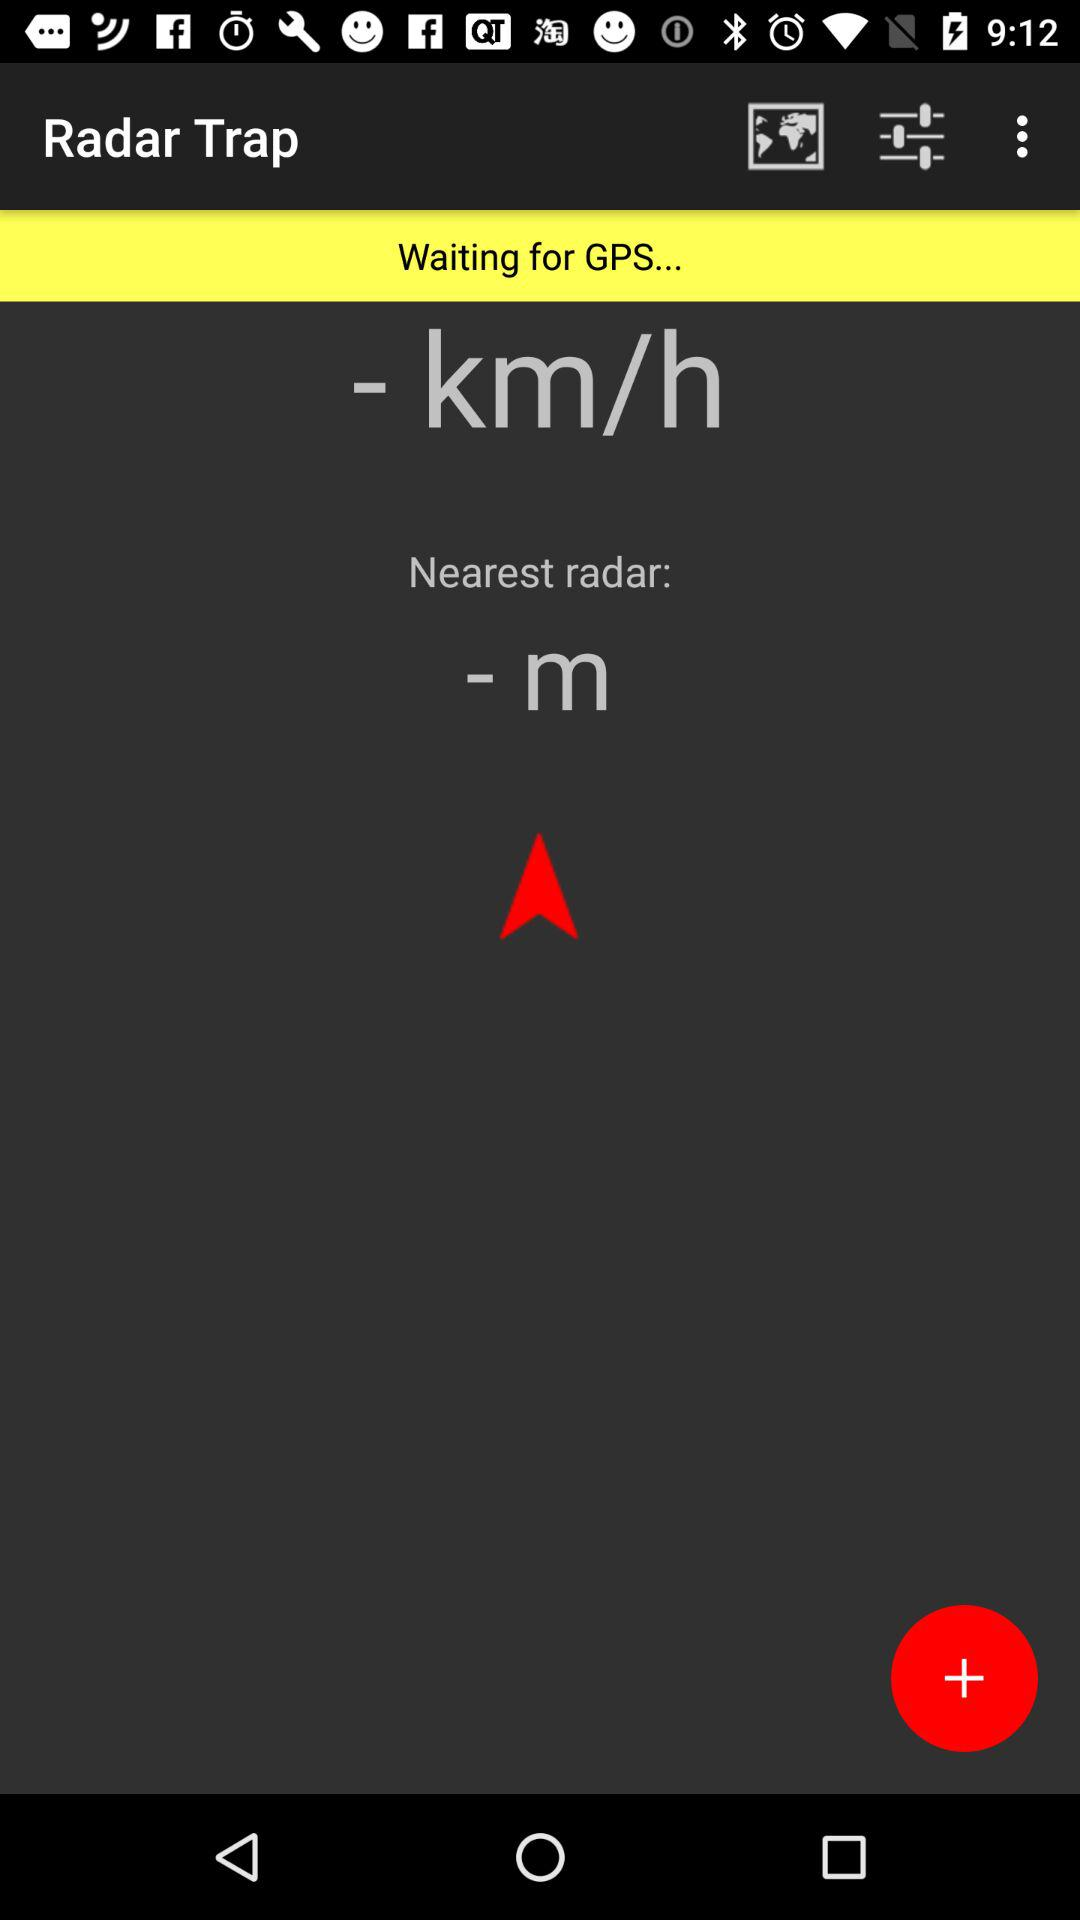What is the name of the application? The name of the application is "Radar Trap". 